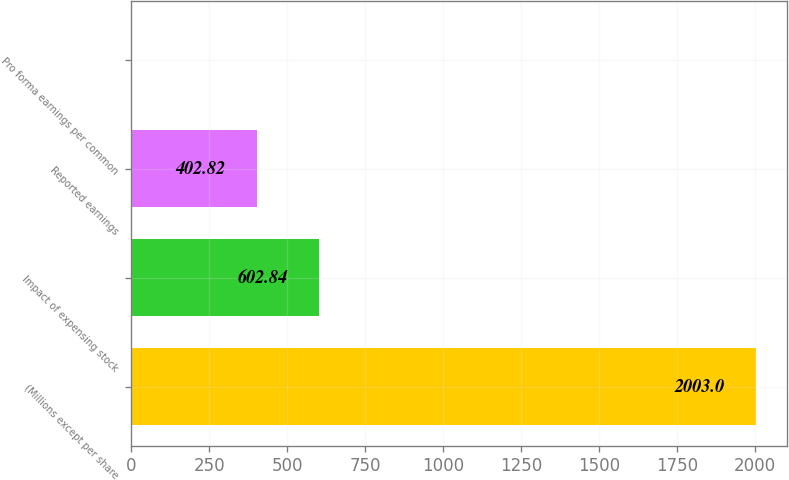<chart> <loc_0><loc_0><loc_500><loc_500><bar_chart><fcel>(Millions except per share<fcel>Impact of expensing stock<fcel>Reported earnings<fcel>Pro forma earnings per common<nl><fcel>2003<fcel>602.84<fcel>402.82<fcel>2.78<nl></chart> 